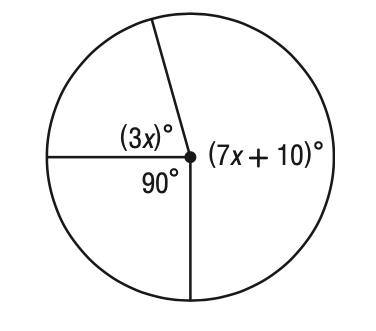Question: What is the value of x in the figure?
Choices:
A. 19
B. 23
C. 26
D. 28
Answer with the letter. Answer: C 